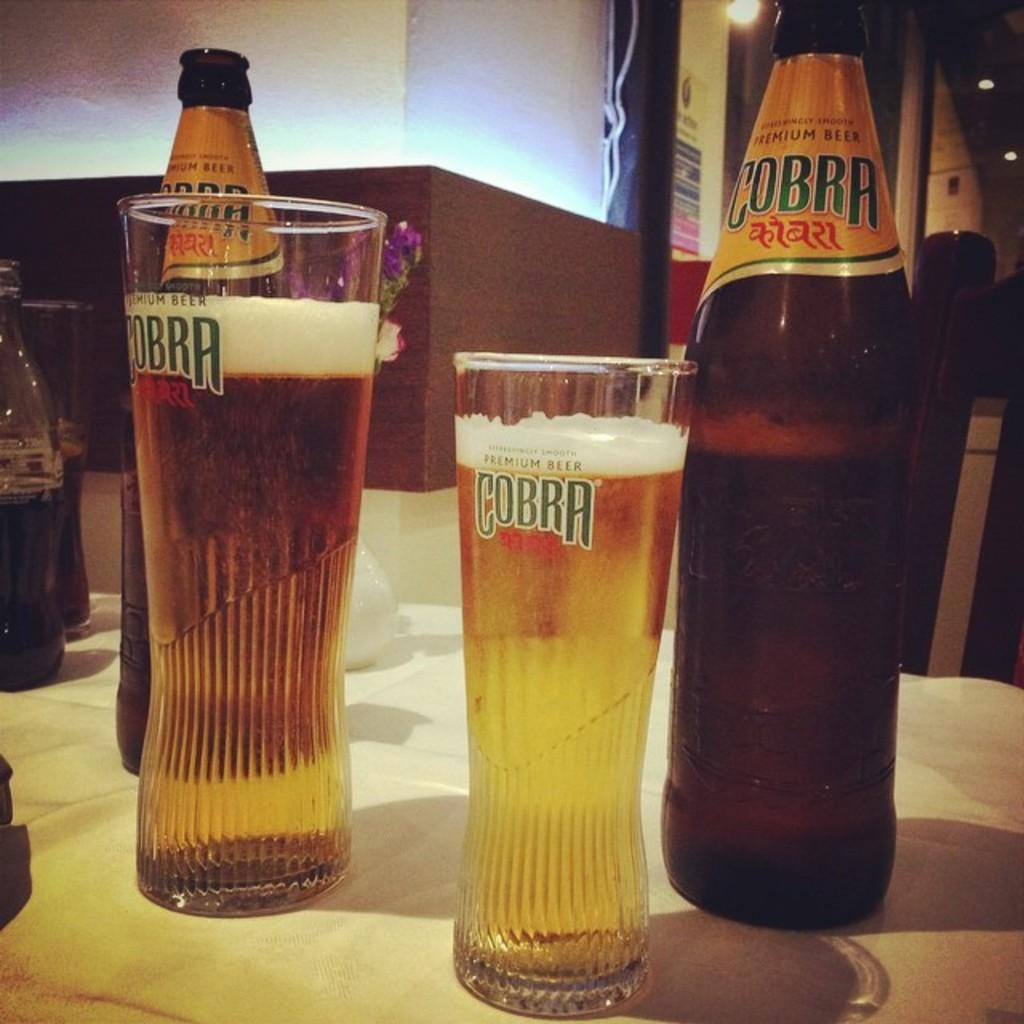What type of beverage containers are present in the image? There are wine bottles in the image. What can be found on the table in the image? There are glasses on the table in the image. What is visible in the background of the image? There is a light and a board attached to the wall in the background of the image. What is the rate of the bike in the image? There is no bike present in the image, so it is not possible to determine its rate. 